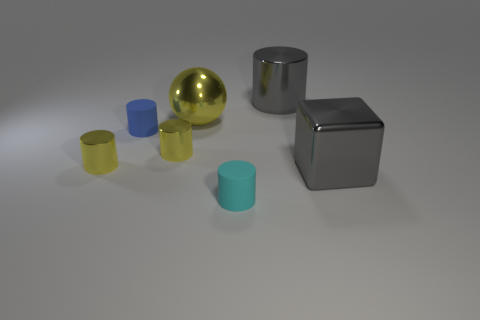Subtract all gray shiny cylinders. How many cylinders are left? 4 Subtract all gray cylinders. How many cylinders are left? 4 Add 1 yellow shiny cylinders. How many objects exist? 8 Subtract 1 balls. How many balls are left? 0 Subtract all balls. How many objects are left? 6 Subtract all cyan balls. How many green cubes are left? 0 Add 5 big gray shiny cylinders. How many big gray shiny cylinders are left? 6 Add 7 tiny blue matte objects. How many tiny blue matte objects exist? 8 Subtract 0 green cylinders. How many objects are left? 7 Subtract all red blocks. Subtract all gray cylinders. How many blocks are left? 1 